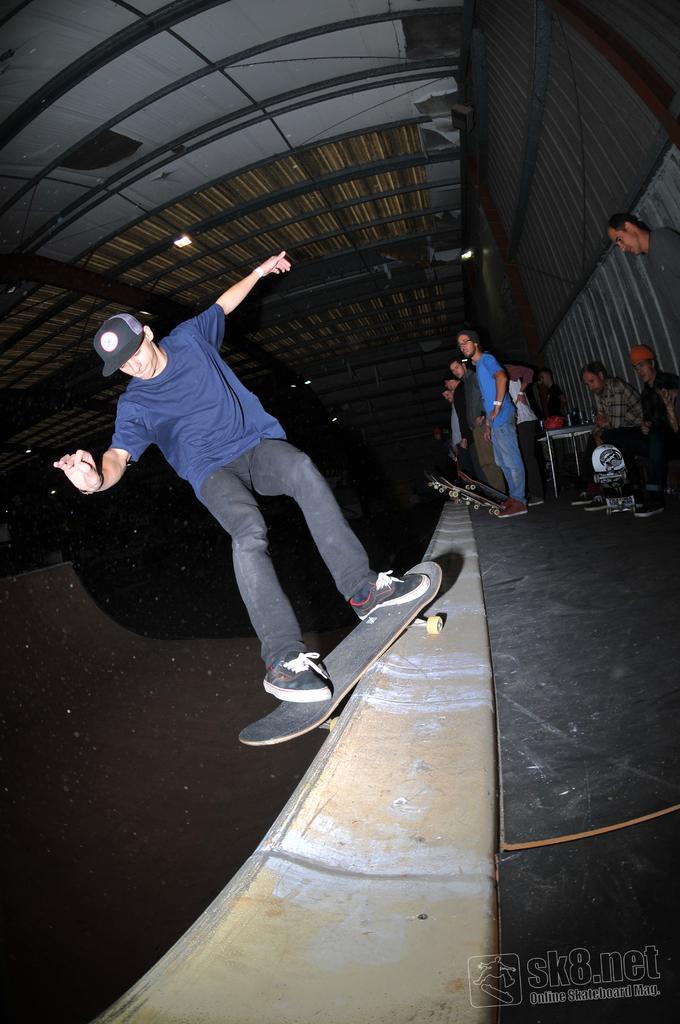Describe this image in one or two sentences. Here we can see a person riding a skateboard on a surface. There are few people and two of them are sitting. Here we can see a table. In the background we can see lights and roof. 